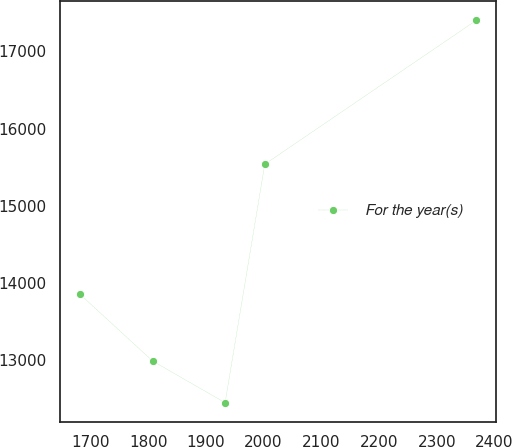<chart> <loc_0><loc_0><loc_500><loc_500><line_chart><ecel><fcel>For the year(s)<nl><fcel>1681.37<fcel>13855.2<nl><fcel>1807.54<fcel>12987.5<nl><fcel>1933.26<fcel>12446.3<nl><fcel>2001.99<fcel>15537<nl><fcel>2368.67<fcel>17403.5<nl></chart> 